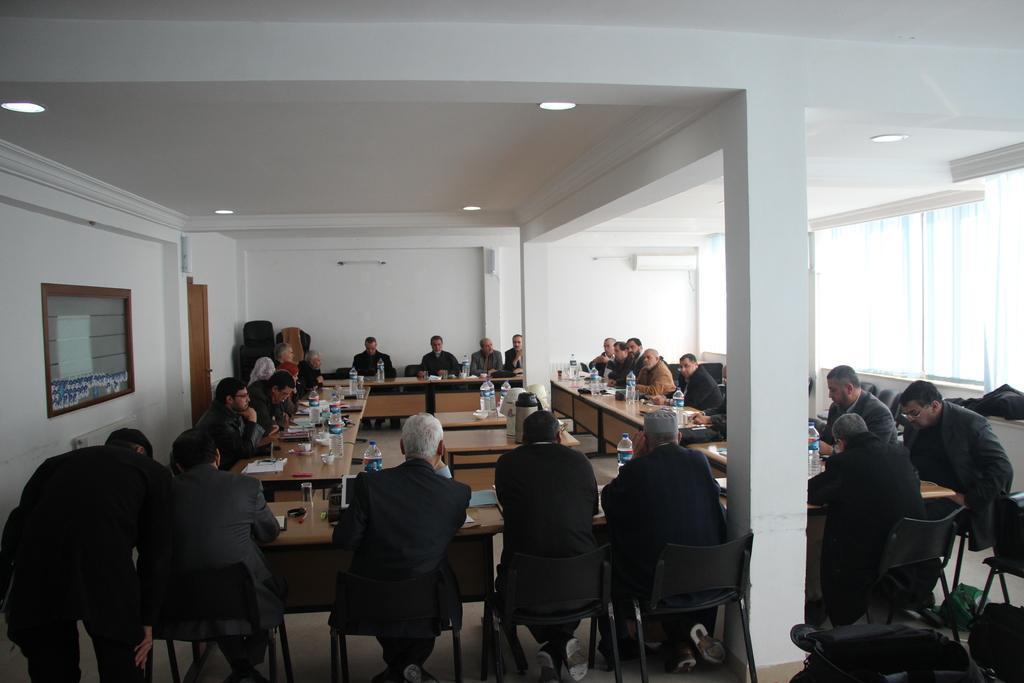How would you summarize this image in a sentence or two? This is a room looks like a conference hall and group of people are sitting on the chair. It looks like a meeting is going on here. On the table we can see water bottles,glass and few papers. There is a pillar here. On the roof top we can see lights and here on the right there is a window with curtains. 